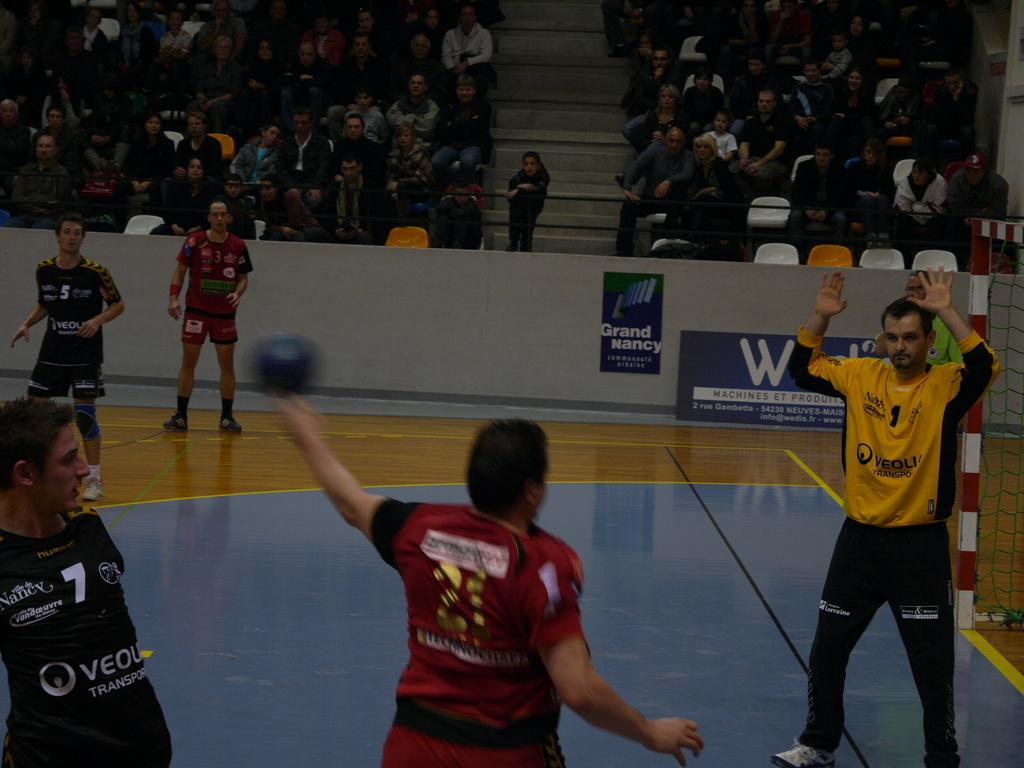Provide a one-sentence caption for the provided image. Player number 1 wears a yellow jersey and holds both of his hands up. 